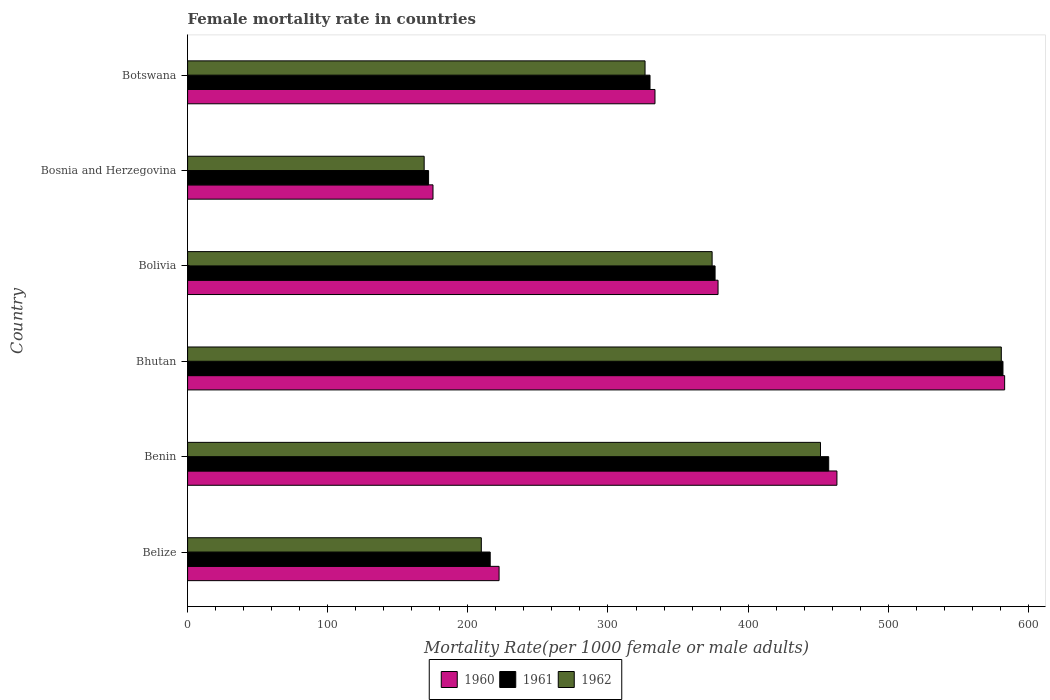Are the number of bars per tick equal to the number of legend labels?
Keep it short and to the point. Yes. How many bars are there on the 5th tick from the top?
Give a very brief answer. 3. How many bars are there on the 2nd tick from the bottom?
Make the answer very short. 3. What is the label of the 5th group of bars from the top?
Make the answer very short. Benin. What is the female mortality rate in 1960 in Bosnia and Herzegovina?
Provide a short and direct response. 175.12. Across all countries, what is the maximum female mortality rate in 1961?
Give a very brief answer. 581.88. Across all countries, what is the minimum female mortality rate in 1962?
Offer a very short reply. 168.83. In which country was the female mortality rate in 1961 maximum?
Give a very brief answer. Bhutan. In which country was the female mortality rate in 1961 minimum?
Give a very brief answer. Bosnia and Herzegovina. What is the total female mortality rate in 1961 in the graph?
Your response must be concise. 2133.75. What is the difference between the female mortality rate in 1960 in Benin and that in Bhutan?
Your answer should be very brief. -119.69. What is the difference between the female mortality rate in 1961 in Bhutan and the female mortality rate in 1960 in Bosnia and Herzegovina?
Give a very brief answer. 406.75. What is the average female mortality rate in 1962 per country?
Offer a very short reply. 351.93. What is the difference between the female mortality rate in 1961 and female mortality rate in 1960 in Benin?
Give a very brief answer. -5.86. What is the ratio of the female mortality rate in 1960 in Benin to that in Bolivia?
Give a very brief answer. 1.22. Is the female mortality rate in 1960 in Belize less than that in Benin?
Give a very brief answer. Yes. What is the difference between the highest and the second highest female mortality rate in 1961?
Offer a very short reply. 124.36. What is the difference between the highest and the lowest female mortality rate in 1962?
Your answer should be very brief. 411.86. Are all the bars in the graph horizontal?
Give a very brief answer. Yes. How many countries are there in the graph?
Provide a short and direct response. 6. Does the graph contain any zero values?
Provide a succinct answer. No. How many legend labels are there?
Offer a very short reply. 3. How are the legend labels stacked?
Give a very brief answer. Horizontal. What is the title of the graph?
Your answer should be very brief. Female mortality rate in countries. What is the label or title of the X-axis?
Your answer should be very brief. Mortality Rate(per 1000 female or male adults). What is the Mortality Rate(per 1000 female or male adults) in 1960 in Belize?
Offer a very short reply. 222.28. What is the Mortality Rate(per 1000 female or male adults) in 1961 in Belize?
Offer a terse response. 215.95. What is the Mortality Rate(per 1000 female or male adults) in 1962 in Belize?
Your response must be concise. 209.62. What is the Mortality Rate(per 1000 female or male adults) in 1960 in Benin?
Your answer should be compact. 463.38. What is the Mortality Rate(per 1000 female or male adults) in 1961 in Benin?
Your answer should be compact. 457.52. What is the Mortality Rate(per 1000 female or male adults) of 1962 in Benin?
Offer a very short reply. 451.66. What is the Mortality Rate(per 1000 female or male adults) of 1960 in Bhutan?
Provide a succinct answer. 583.07. What is the Mortality Rate(per 1000 female or male adults) of 1961 in Bhutan?
Your response must be concise. 581.88. What is the Mortality Rate(per 1000 female or male adults) in 1962 in Bhutan?
Your response must be concise. 580.69. What is the Mortality Rate(per 1000 female or male adults) of 1960 in Bolivia?
Your response must be concise. 378.54. What is the Mortality Rate(per 1000 female or male adults) in 1961 in Bolivia?
Ensure brevity in your answer.  376.43. What is the Mortality Rate(per 1000 female or male adults) in 1962 in Bolivia?
Your answer should be compact. 374.32. What is the Mortality Rate(per 1000 female or male adults) in 1960 in Bosnia and Herzegovina?
Provide a succinct answer. 175.12. What is the Mortality Rate(per 1000 female or male adults) of 1961 in Bosnia and Herzegovina?
Offer a very short reply. 171.98. What is the Mortality Rate(per 1000 female or male adults) in 1962 in Bosnia and Herzegovina?
Provide a succinct answer. 168.83. What is the Mortality Rate(per 1000 female or male adults) of 1960 in Botswana?
Keep it short and to the point. 333.54. What is the Mortality Rate(per 1000 female or male adults) of 1961 in Botswana?
Give a very brief answer. 330. What is the Mortality Rate(per 1000 female or male adults) in 1962 in Botswana?
Make the answer very short. 326.45. Across all countries, what is the maximum Mortality Rate(per 1000 female or male adults) in 1960?
Offer a terse response. 583.07. Across all countries, what is the maximum Mortality Rate(per 1000 female or male adults) in 1961?
Provide a succinct answer. 581.88. Across all countries, what is the maximum Mortality Rate(per 1000 female or male adults) of 1962?
Offer a very short reply. 580.69. Across all countries, what is the minimum Mortality Rate(per 1000 female or male adults) of 1960?
Give a very brief answer. 175.12. Across all countries, what is the minimum Mortality Rate(per 1000 female or male adults) of 1961?
Your answer should be very brief. 171.98. Across all countries, what is the minimum Mortality Rate(per 1000 female or male adults) in 1962?
Make the answer very short. 168.83. What is the total Mortality Rate(per 1000 female or male adults) in 1960 in the graph?
Provide a succinct answer. 2155.93. What is the total Mortality Rate(per 1000 female or male adults) in 1961 in the graph?
Provide a short and direct response. 2133.75. What is the total Mortality Rate(per 1000 female or male adults) in 1962 in the graph?
Make the answer very short. 2111.57. What is the difference between the Mortality Rate(per 1000 female or male adults) in 1960 in Belize and that in Benin?
Offer a very short reply. -241.1. What is the difference between the Mortality Rate(per 1000 female or male adults) of 1961 in Belize and that in Benin?
Offer a very short reply. -241.57. What is the difference between the Mortality Rate(per 1000 female or male adults) in 1962 in Belize and that in Benin?
Keep it short and to the point. -242.04. What is the difference between the Mortality Rate(per 1000 female or male adults) in 1960 in Belize and that in Bhutan?
Provide a succinct answer. -360.79. What is the difference between the Mortality Rate(per 1000 female or male adults) in 1961 in Belize and that in Bhutan?
Your response must be concise. -365.93. What is the difference between the Mortality Rate(per 1000 female or male adults) in 1962 in Belize and that in Bhutan?
Ensure brevity in your answer.  -371.07. What is the difference between the Mortality Rate(per 1000 female or male adults) of 1960 in Belize and that in Bolivia?
Give a very brief answer. -156.26. What is the difference between the Mortality Rate(per 1000 female or male adults) in 1961 in Belize and that in Bolivia?
Provide a short and direct response. -160.48. What is the difference between the Mortality Rate(per 1000 female or male adults) of 1962 in Belize and that in Bolivia?
Your answer should be very brief. -164.7. What is the difference between the Mortality Rate(per 1000 female or male adults) in 1960 in Belize and that in Bosnia and Herzegovina?
Your response must be concise. 47.16. What is the difference between the Mortality Rate(per 1000 female or male adults) in 1961 in Belize and that in Bosnia and Herzegovina?
Offer a terse response. 43.97. What is the difference between the Mortality Rate(per 1000 female or male adults) of 1962 in Belize and that in Bosnia and Herzegovina?
Keep it short and to the point. 40.79. What is the difference between the Mortality Rate(per 1000 female or male adults) in 1960 in Belize and that in Botswana?
Provide a short and direct response. -111.26. What is the difference between the Mortality Rate(per 1000 female or male adults) of 1961 in Belize and that in Botswana?
Offer a very short reply. -114.05. What is the difference between the Mortality Rate(per 1000 female or male adults) in 1962 in Belize and that in Botswana?
Your answer should be very brief. -116.83. What is the difference between the Mortality Rate(per 1000 female or male adults) in 1960 in Benin and that in Bhutan?
Offer a terse response. -119.69. What is the difference between the Mortality Rate(per 1000 female or male adults) of 1961 in Benin and that in Bhutan?
Your response must be concise. -124.36. What is the difference between the Mortality Rate(per 1000 female or male adults) of 1962 in Benin and that in Bhutan?
Your answer should be very brief. -129.03. What is the difference between the Mortality Rate(per 1000 female or male adults) of 1960 in Benin and that in Bolivia?
Provide a short and direct response. 84.83. What is the difference between the Mortality Rate(per 1000 female or male adults) of 1961 in Benin and that in Bolivia?
Keep it short and to the point. 81.09. What is the difference between the Mortality Rate(per 1000 female or male adults) in 1962 in Benin and that in Bolivia?
Your response must be concise. 77.34. What is the difference between the Mortality Rate(per 1000 female or male adults) of 1960 in Benin and that in Bosnia and Herzegovina?
Your answer should be compact. 288.25. What is the difference between the Mortality Rate(per 1000 female or male adults) in 1961 in Benin and that in Bosnia and Herzegovina?
Your answer should be compact. 285.54. What is the difference between the Mortality Rate(per 1000 female or male adults) of 1962 in Benin and that in Bosnia and Herzegovina?
Make the answer very short. 282.83. What is the difference between the Mortality Rate(per 1000 female or male adults) of 1960 in Benin and that in Botswana?
Your response must be concise. 129.83. What is the difference between the Mortality Rate(per 1000 female or male adults) of 1961 in Benin and that in Botswana?
Give a very brief answer. 127.52. What is the difference between the Mortality Rate(per 1000 female or male adults) of 1962 in Benin and that in Botswana?
Your response must be concise. 125.21. What is the difference between the Mortality Rate(per 1000 female or male adults) of 1960 in Bhutan and that in Bolivia?
Offer a terse response. 204.53. What is the difference between the Mortality Rate(per 1000 female or male adults) of 1961 in Bhutan and that in Bolivia?
Offer a very short reply. 205.45. What is the difference between the Mortality Rate(per 1000 female or male adults) in 1962 in Bhutan and that in Bolivia?
Keep it short and to the point. 206.37. What is the difference between the Mortality Rate(per 1000 female or male adults) in 1960 in Bhutan and that in Bosnia and Herzegovina?
Your answer should be very brief. 407.94. What is the difference between the Mortality Rate(per 1000 female or male adults) of 1961 in Bhutan and that in Bosnia and Herzegovina?
Your answer should be very brief. 409.9. What is the difference between the Mortality Rate(per 1000 female or male adults) of 1962 in Bhutan and that in Bosnia and Herzegovina?
Offer a very short reply. 411.86. What is the difference between the Mortality Rate(per 1000 female or male adults) in 1960 in Bhutan and that in Botswana?
Keep it short and to the point. 249.52. What is the difference between the Mortality Rate(per 1000 female or male adults) in 1961 in Bhutan and that in Botswana?
Provide a short and direct response. 251.88. What is the difference between the Mortality Rate(per 1000 female or male adults) of 1962 in Bhutan and that in Botswana?
Give a very brief answer. 254.23. What is the difference between the Mortality Rate(per 1000 female or male adults) of 1960 in Bolivia and that in Bosnia and Herzegovina?
Offer a terse response. 203.42. What is the difference between the Mortality Rate(per 1000 female or male adults) in 1961 in Bolivia and that in Bosnia and Herzegovina?
Ensure brevity in your answer.  204.45. What is the difference between the Mortality Rate(per 1000 female or male adults) of 1962 in Bolivia and that in Bosnia and Herzegovina?
Ensure brevity in your answer.  205.49. What is the difference between the Mortality Rate(per 1000 female or male adults) of 1960 in Bolivia and that in Botswana?
Your answer should be compact. 45. What is the difference between the Mortality Rate(per 1000 female or male adults) in 1961 in Bolivia and that in Botswana?
Provide a short and direct response. 46.43. What is the difference between the Mortality Rate(per 1000 female or male adults) in 1962 in Bolivia and that in Botswana?
Give a very brief answer. 47.86. What is the difference between the Mortality Rate(per 1000 female or male adults) in 1960 in Bosnia and Herzegovina and that in Botswana?
Your answer should be very brief. -158.42. What is the difference between the Mortality Rate(per 1000 female or male adults) of 1961 in Bosnia and Herzegovina and that in Botswana?
Your answer should be compact. -158.02. What is the difference between the Mortality Rate(per 1000 female or male adults) of 1962 in Bosnia and Herzegovina and that in Botswana?
Provide a succinct answer. -157.62. What is the difference between the Mortality Rate(per 1000 female or male adults) of 1960 in Belize and the Mortality Rate(per 1000 female or male adults) of 1961 in Benin?
Ensure brevity in your answer.  -235.24. What is the difference between the Mortality Rate(per 1000 female or male adults) in 1960 in Belize and the Mortality Rate(per 1000 female or male adults) in 1962 in Benin?
Give a very brief answer. -229.38. What is the difference between the Mortality Rate(per 1000 female or male adults) of 1961 in Belize and the Mortality Rate(per 1000 female or male adults) of 1962 in Benin?
Provide a succinct answer. -235.71. What is the difference between the Mortality Rate(per 1000 female or male adults) of 1960 in Belize and the Mortality Rate(per 1000 female or male adults) of 1961 in Bhutan?
Make the answer very short. -359.6. What is the difference between the Mortality Rate(per 1000 female or male adults) in 1960 in Belize and the Mortality Rate(per 1000 female or male adults) in 1962 in Bhutan?
Make the answer very short. -358.41. What is the difference between the Mortality Rate(per 1000 female or male adults) of 1961 in Belize and the Mortality Rate(per 1000 female or male adults) of 1962 in Bhutan?
Give a very brief answer. -364.74. What is the difference between the Mortality Rate(per 1000 female or male adults) in 1960 in Belize and the Mortality Rate(per 1000 female or male adults) in 1961 in Bolivia?
Your answer should be compact. -154.15. What is the difference between the Mortality Rate(per 1000 female or male adults) in 1960 in Belize and the Mortality Rate(per 1000 female or male adults) in 1962 in Bolivia?
Your answer should be very brief. -152.04. What is the difference between the Mortality Rate(per 1000 female or male adults) of 1961 in Belize and the Mortality Rate(per 1000 female or male adults) of 1962 in Bolivia?
Make the answer very short. -158.37. What is the difference between the Mortality Rate(per 1000 female or male adults) of 1960 in Belize and the Mortality Rate(per 1000 female or male adults) of 1961 in Bosnia and Herzegovina?
Provide a succinct answer. 50.3. What is the difference between the Mortality Rate(per 1000 female or male adults) of 1960 in Belize and the Mortality Rate(per 1000 female or male adults) of 1962 in Bosnia and Herzegovina?
Provide a succinct answer. 53.45. What is the difference between the Mortality Rate(per 1000 female or male adults) of 1961 in Belize and the Mortality Rate(per 1000 female or male adults) of 1962 in Bosnia and Herzegovina?
Provide a short and direct response. 47.12. What is the difference between the Mortality Rate(per 1000 female or male adults) of 1960 in Belize and the Mortality Rate(per 1000 female or male adults) of 1961 in Botswana?
Offer a very short reply. -107.72. What is the difference between the Mortality Rate(per 1000 female or male adults) of 1960 in Belize and the Mortality Rate(per 1000 female or male adults) of 1962 in Botswana?
Offer a terse response. -104.17. What is the difference between the Mortality Rate(per 1000 female or male adults) of 1961 in Belize and the Mortality Rate(per 1000 female or male adults) of 1962 in Botswana?
Your response must be concise. -110.5. What is the difference between the Mortality Rate(per 1000 female or male adults) of 1960 in Benin and the Mortality Rate(per 1000 female or male adults) of 1961 in Bhutan?
Your answer should be compact. -118.5. What is the difference between the Mortality Rate(per 1000 female or male adults) in 1960 in Benin and the Mortality Rate(per 1000 female or male adults) in 1962 in Bhutan?
Give a very brief answer. -117.31. What is the difference between the Mortality Rate(per 1000 female or male adults) in 1961 in Benin and the Mortality Rate(per 1000 female or male adults) in 1962 in Bhutan?
Make the answer very short. -123.17. What is the difference between the Mortality Rate(per 1000 female or male adults) in 1960 in Benin and the Mortality Rate(per 1000 female or male adults) in 1961 in Bolivia?
Keep it short and to the point. 86.95. What is the difference between the Mortality Rate(per 1000 female or male adults) in 1960 in Benin and the Mortality Rate(per 1000 female or male adults) in 1962 in Bolivia?
Keep it short and to the point. 89.06. What is the difference between the Mortality Rate(per 1000 female or male adults) in 1961 in Benin and the Mortality Rate(per 1000 female or male adults) in 1962 in Bolivia?
Your answer should be very brief. 83.2. What is the difference between the Mortality Rate(per 1000 female or male adults) of 1960 in Benin and the Mortality Rate(per 1000 female or male adults) of 1961 in Bosnia and Herzegovina?
Your answer should be very brief. 291.4. What is the difference between the Mortality Rate(per 1000 female or male adults) in 1960 in Benin and the Mortality Rate(per 1000 female or male adults) in 1962 in Bosnia and Herzegovina?
Offer a very short reply. 294.55. What is the difference between the Mortality Rate(per 1000 female or male adults) in 1961 in Benin and the Mortality Rate(per 1000 female or male adults) in 1962 in Bosnia and Herzegovina?
Your response must be concise. 288.69. What is the difference between the Mortality Rate(per 1000 female or male adults) of 1960 in Benin and the Mortality Rate(per 1000 female or male adults) of 1961 in Botswana?
Offer a very short reply. 133.38. What is the difference between the Mortality Rate(per 1000 female or male adults) in 1960 in Benin and the Mortality Rate(per 1000 female or male adults) in 1962 in Botswana?
Provide a short and direct response. 136.92. What is the difference between the Mortality Rate(per 1000 female or male adults) of 1961 in Benin and the Mortality Rate(per 1000 female or male adults) of 1962 in Botswana?
Offer a very short reply. 131.06. What is the difference between the Mortality Rate(per 1000 female or male adults) of 1960 in Bhutan and the Mortality Rate(per 1000 female or male adults) of 1961 in Bolivia?
Make the answer very short. 206.64. What is the difference between the Mortality Rate(per 1000 female or male adults) of 1960 in Bhutan and the Mortality Rate(per 1000 female or male adults) of 1962 in Bolivia?
Provide a short and direct response. 208.75. What is the difference between the Mortality Rate(per 1000 female or male adults) in 1961 in Bhutan and the Mortality Rate(per 1000 female or male adults) in 1962 in Bolivia?
Your answer should be very brief. 207.56. What is the difference between the Mortality Rate(per 1000 female or male adults) of 1960 in Bhutan and the Mortality Rate(per 1000 female or male adults) of 1961 in Bosnia and Herzegovina?
Offer a very short reply. 411.09. What is the difference between the Mortality Rate(per 1000 female or male adults) of 1960 in Bhutan and the Mortality Rate(per 1000 female or male adults) of 1962 in Bosnia and Herzegovina?
Offer a terse response. 414.24. What is the difference between the Mortality Rate(per 1000 female or male adults) of 1961 in Bhutan and the Mortality Rate(per 1000 female or male adults) of 1962 in Bosnia and Herzegovina?
Offer a terse response. 413.05. What is the difference between the Mortality Rate(per 1000 female or male adults) in 1960 in Bhutan and the Mortality Rate(per 1000 female or male adults) in 1961 in Botswana?
Provide a short and direct response. 253.07. What is the difference between the Mortality Rate(per 1000 female or male adults) of 1960 in Bhutan and the Mortality Rate(per 1000 female or male adults) of 1962 in Botswana?
Offer a very short reply. 256.61. What is the difference between the Mortality Rate(per 1000 female or male adults) in 1961 in Bhutan and the Mortality Rate(per 1000 female or male adults) in 1962 in Botswana?
Ensure brevity in your answer.  255.42. What is the difference between the Mortality Rate(per 1000 female or male adults) of 1960 in Bolivia and the Mortality Rate(per 1000 female or male adults) of 1961 in Bosnia and Herzegovina?
Provide a succinct answer. 206.57. What is the difference between the Mortality Rate(per 1000 female or male adults) in 1960 in Bolivia and the Mortality Rate(per 1000 female or male adults) in 1962 in Bosnia and Herzegovina?
Provide a succinct answer. 209.71. What is the difference between the Mortality Rate(per 1000 female or male adults) of 1961 in Bolivia and the Mortality Rate(per 1000 female or male adults) of 1962 in Bosnia and Herzegovina?
Your answer should be compact. 207.6. What is the difference between the Mortality Rate(per 1000 female or male adults) in 1960 in Bolivia and the Mortality Rate(per 1000 female or male adults) in 1961 in Botswana?
Your answer should be very brief. 48.54. What is the difference between the Mortality Rate(per 1000 female or male adults) in 1960 in Bolivia and the Mortality Rate(per 1000 female or male adults) in 1962 in Botswana?
Provide a short and direct response. 52.09. What is the difference between the Mortality Rate(per 1000 female or male adults) in 1961 in Bolivia and the Mortality Rate(per 1000 female or male adults) in 1962 in Botswana?
Make the answer very short. 49.98. What is the difference between the Mortality Rate(per 1000 female or male adults) of 1960 in Bosnia and Herzegovina and the Mortality Rate(per 1000 female or male adults) of 1961 in Botswana?
Your answer should be very brief. -154.88. What is the difference between the Mortality Rate(per 1000 female or male adults) of 1960 in Bosnia and Herzegovina and the Mortality Rate(per 1000 female or male adults) of 1962 in Botswana?
Your answer should be very brief. -151.33. What is the difference between the Mortality Rate(per 1000 female or male adults) of 1961 in Bosnia and Herzegovina and the Mortality Rate(per 1000 female or male adults) of 1962 in Botswana?
Provide a succinct answer. -154.48. What is the average Mortality Rate(per 1000 female or male adults) in 1960 per country?
Your response must be concise. 359.32. What is the average Mortality Rate(per 1000 female or male adults) of 1961 per country?
Provide a succinct answer. 355.62. What is the average Mortality Rate(per 1000 female or male adults) in 1962 per country?
Provide a short and direct response. 351.93. What is the difference between the Mortality Rate(per 1000 female or male adults) in 1960 and Mortality Rate(per 1000 female or male adults) in 1961 in Belize?
Keep it short and to the point. 6.33. What is the difference between the Mortality Rate(per 1000 female or male adults) in 1960 and Mortality Rate(per 1000 female or male adults) in 1962 in Belize?
Your answer should be very brief. 12.66. What is the difference between the Mortality Rate(per 1000 female or male adults) of 1961 and Mortality Rate(per 1000 female or male adults) of 1962 in Belize?
Ensure brevity in your answer.  6.33. What is the difference between the Mortality Rate(per 1000 female or male adults) of 1960 and Mortality Rate(per 1000 female or male adults) of 1961 in Benin?
Your answer should be very brief. 5.86. What is the difference between the Mortality Rate(per 1000 female or male adults) of 1960 and Mortality Rate(per 1000 female or male adults) of 1962 in Benin?
Provide a succinct answer. 11.72. What is the difference between the Mortality Rate(per 1000 female or male adults) of 1961 and Mortality Rate(per 1000 female or male adults) of 1962 in Benin?
Give a very brief answer. 5.86. What is the difference between the Mortality Rate(per 1000 female or male adults) in 1960 and Mortality Rate(per 1000 female or male adults) in 1961 in Bhutan?
Your response must be concise. 1.19. What is the difference between the Mortality Rate(per 1000 female or male adults) of 1960 and Mortality Rate(per 1000 female or male adults) of 1962 in Bhutan?
Ensure brevity in your answer.  2.38. What is the difference between the Mortality Rate(per 1000 female or male adults) in 1961 and Mortality Rate(per 1000 female or male adults) in 1962 in Bhutan?
Offer a very short reply. 1.19. What is the difference between the Mortality Rate(per 1000 female or male adults) in 1960 and Mortality Rate(per 1000 female or male adults) in 1961 in Bolivia?
Your answer should be very brief. 2.11. What is the difference between the Mortality Rate(per 1000 female or male adults) in 1960 and Mortality Rate(per 1000 female or male adults) in 1962 in Bolivia?
Your answer should be compact. 4.22. What is the difference between the Mortality Rate(per 1000 female or male adults) of 1961 and Mortality Rate(per 1000 female or male adults) of 1962 in Bolivia?
Offer a very short reply. 2.11. What is the difference between the Mortality Rate(per 1000 female or male adults) of 1960 and Mortality Rate(per 1000 female or male adults) of 1961 in Bosnia and Herzegovina?
Offer a terse response. 3.15. What is the difference between the Mortality Rate(per 1000 female or male adults) in 1960 and Mortality Rate(per 1000 female or male adults) in 1962 in Bosnia and Herzegovina?
Ensure brevity in your answer.  6.29. What is the difference between the Mortality Rate(per 1000 female or male adults) of 1961 and Mortality Rate(per 1000 female or male adults) of 1962 in Bosnia and Herzegovina?
Ensure brevity in your answer.  3.15. What is the difference between the Mortality Rate(per 1000 female or male adults) of 1960 and Mortality Rate(per 1000 female or male adults) of 1961 in Botswana?
Your answer should be very brief. 3.54. What is the difference between the Mortality Rate(per 1000 female or male adults) of 1960 and Mortality Rate(per 1000 female or male adults) of 1962 in Botswana?
Your response must be concise. 7.09. What is the difference between the Mortality Rate(per 1000 female or male adults) of 1961 and Mortality Rate(per 1000 female or male adults) of 1962 in Botswana?
Your response must be concise. 3.54. What is the ratio of the Mortality Rate(per 1000 female or male adults) in 1960 in Belize to that in Benin?
Give a very brief answer. 0.48. What is the ratio of the Mortality Rate(per 1000 female or male adults) of 1961 in Belize to that in Benin?
Your response must be concise. 0.47. What is the ratio of the Mortality Rate(per 1000 female or male adults) in 1962 in Belize to that in Benin?
Make the answer very short. 0.46. What is the ratio of the Mortality Rate(per 1000 female or male adults) in 1960 in Belize to that in Bhutan?
Your answer should be very brief. 0.38. What is the ratio of the Mortality Rate(per 1000 female or male adults) of 1961 in Belize to that in Bhutan?
Offer a terse response. 0.37. What is the ratio of the Mortality Rate(per 1000 female or male adults) of 1962 in Belize to that in Bhutan?
Your answer should be compact. 0.36. What is the ratio of the Mortality Rate(per 1000 female or male adults) of 1960 in Belize to that in Bolivia?
Provide a succinct answer. 0.59. What is the ratio of the Mortality Rate(per 1000 female or male adults) of 1961 in Belize to that in Bolivia?
Ensure brevity in your answer.  0.57. What is the ratio of the Mortality Rate(per 1000 female or male adults) of 1962 in Belize to that in Bolivia?
Ensure brevity in your answer.  0.56. What is the ratio of the Mortality Rate(per 1000 female or male adults) of 1960 in Belize to that in Bosnia and Herzegovina?
Provide a succinct answer. 1.27. What is the ratio of the Mortality Rate(per 1000 female or male adults) in 1961 in Belize to that in Bosnia and Herzegovina?
Give a very brief answer. 1.26. What is the ratio of the Mortality Rate(per 1000 female or male adults) of 1962 in Belize to that in Bosnia and Herzegovina?
Provide a succinct answer. 1.24. What is the ratio of the Mortality Rate(per 1000 female or male adults) of 1960 in Belize to that in Botswana?
Ensure brevity in your answer.  0.67. What is the ratio of the Mortality Rate(per 1000 female or male adults) in 1961 in Belize to that in Botswana?
Offer a very short reply. 0.65. What is the ratio of the Mortality Rate(per 1000 female or male adults) of 1962 in Belize to that in Botswana?
Your answer should be very brief. 0.64. What is the ratio of the Mortality Rate(per 1000 female or male adults) in 1960 in Benin to that in Bhutan?
Your response must be concise. 0.79. What is the ratio of the Mortality Rate(per 1000 female or male adults) in 1961 in Benin to that in Bhutan?
Give a very brief answer. 0.79. What is the ratio of the Mortality Rate(per 1000 female or male adults) of 1960 in Benin to that in Bolivia?
Your answer should be compact. 1.22. What is the ratio of the Mortality Rate(per 1000 female or male adults) in 1961 in Benin to that in Bolivia?
Provide a succinct answer. 1.22. What is the ratio of the Mortality Rate(per 1000 female or male adults) of 1962 in Benin to that in Bolivia?
Give a very brief answer. 1.21. What is the ratio of the Mortality Rate(per 1000 female or male adults) in 1960 in Benin to that in Bosnia and Herzegovina?
Offer a terse response. 2.65. What is the ratio of the Mortality Rate(per 1000 female or male adults) in 1961 in Benin to that in Bosnia and Herzegovina?
Provide a succinct answer. 2.66. What is the ratio of the Mortality Rate(per 1000 female or male adults) of 1962 in Benin to that in Bosnia and Herzegovina?
Make the answer very short. 2.68. What is the ratio of the Mortality Rate(per 1000 female or male adults) in 1960 in Benin to that in Botswana?
Your answer should be very brief. 1.39. What is the ratio of the Mortality Rate(per 1000 female or male adults) in 1961 in Benin to that in Botswana?
Offer a very short reply. 1.39. What is the ratio of the Mortality Rate(per 1000 female or male adults) in 1962 in Benin to that in Botswana?
Provide a short and direct response. 1.38. What is the ratio of the Mortality Rate(per 1000 female or male adults) of 1960 in Bhutan to that in Bolivia?
Your answer should be very brief. 1.54. What is the ratio of the Mortality Rate(per 1000 female or male adults) of 1961 in Bhutan to that in Bolivia?
Give a very brief answer. 1.55. What is the ratio of the Mortality Rate(per 1000 female or male adults) in 1962 in Bhutan to that in Bolivia?
Provide a succinct answer. 1.55. What is the ratio of the Mortality Rate(per 1000 female or male adults) of 1960 in Bhutan to that in Bosnia and Herzegovina?
Your answer should be very brief. 3.33. What is the ratio of the Mortality Rate(per 1000 female or male adults) of 1961 in Bhutan to that in Bosnia and Herzegovina?
Make the answer very short. 3.38. What is the ratio of the Mortality Rate(per 1000 female or male adults) of 1962 in Bhutan to that in Bosnia and Herzegovina?
Your answer should be compact. 3.44. What is the ratio of the Mortality Rate(per 1000 female or male adults) of 1960 in Bhutan to that in Botswana?
Ensure brevity in your answer.  1.75. What is the ratio of the Mortality Rate(per 1000 female or male adults) in 1961 in Bhutan to that in Botswana?
Provide a short and direct response. 1.76. What is the ratio of the Mortality Rate(per 1000 female or male adults) of 1962 in Bhutan to that in Botswana?
Your response must be concise. 1.78. What is the ratio of the Mortality Rate(per 1000 female or male adults) in 1960 in Bolivia to that in Bosnia and Herzegovina?
Your answer should be compact. 2.16. What is the ratio of the Mortality Rate(per 1000 female or male adults) in 1961 in Bolivia to that in Bosnia and Herzegovina?
Provide a succinct answer. 2.19. What is the ratio of the Mortality Rate(per 1000 female or male adults) of 1962 in Bolivia to that in Bosnia and Herzegovina?
Offer a terse response. 2.22. What is the ratio of the Mortality Rate(per 1000 female or male adults) in 1960 in Bolivia to that in Botswana?
Ensure brevity in your answer.  1.13. What is the ratio of the Mortality Rate(per 1000 female or male adults) in 1961 in Bolivia to that in Botswana?
Offer a very short reply. 1.14. What is the ratio of the Mortality Rate(per 1000 female or male adults) of 1962 in Bolivia to that in Botswana?
Keep it short and to the point. 1.15. What is the ratio of the Mortality Rate(per 1000 female or male adults) of 1960 in Bosnia and Herzegovina to that in Botswana?
Provide a succinct answer. 0.53. What is the ratio of the Mortality Rate(per 1000 female or male adults) of 1961 in Bosnia and Herzegovina to that in Botswana?
Your answer should be compact. 0.52. What is the ratio of the Mortality Rate(per 1000 female or male adults) of 1962 in Bosnia and Herzegovina to that in Botswana?
Provide a short and direct response. 0.52. What is the difference between the highest and the second highest Mortality Rate(per 1000 female or male adults) of 1960?
Give a very brief answer. 119.69. What is the difference between the highest and the second highest Mortality Rate(per 1000 female or male adults) of 1961?
Your answer should be compact. 124.36. What is the difference between the highest and the second highest Mortality Rate(per 1000 female or male adults) in 1962?
Offer a terse response. 129.03. What is the difference between the highest and the lowest Mortality Rate(per 1000 female or male adults) in 1960?
Provide a succinct answer. 407.94. What is the difference between the highest and the lowest Mortality Rate(per 1000 female or male adults) of 1961?
Provide a succinct answer. 409.9. What is the difference between the highest and the lowest Mortality Rate(per 1000 female or male adults) in 1962?
Your response must be concise. 411.86. 